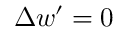<formula> <loc_0><loc_0><loc_500><loc_500>\Delta w ^ { \prime } = 0</formula> 